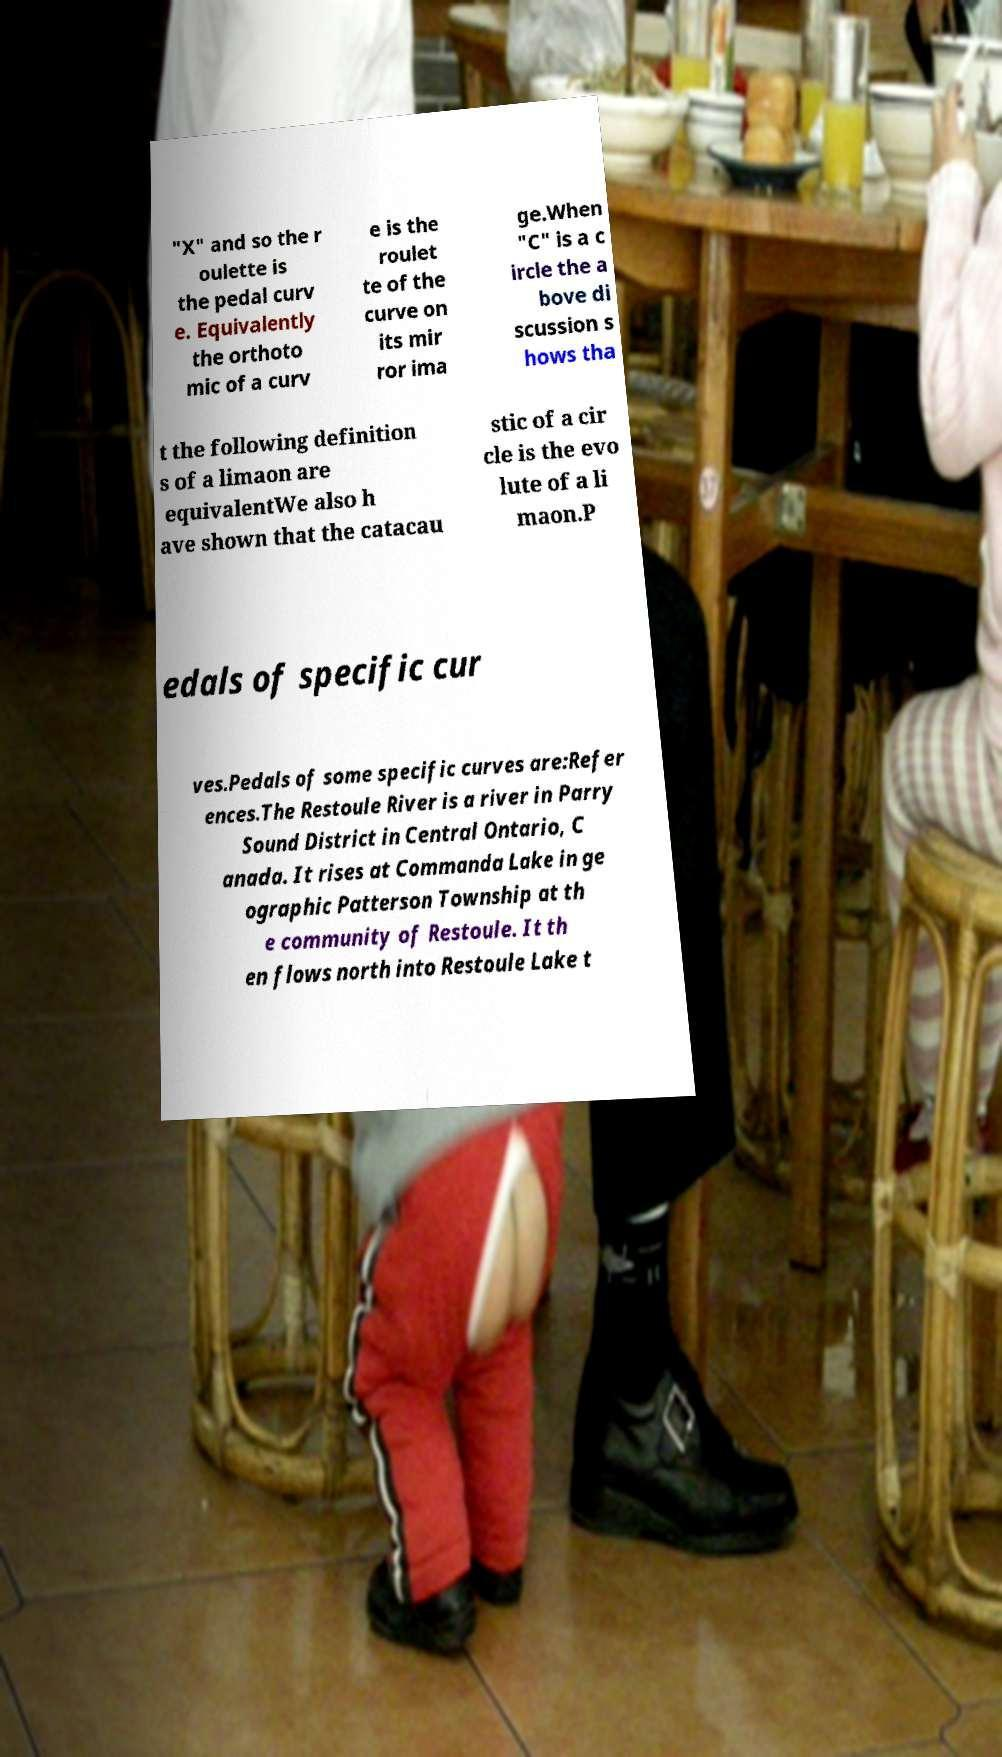For documentation purposes, I need the text within this image transcribed. Could you provide that? "X" and so the r oulette is the pedal curv e. Equivalently the orthoto mic of a curv e is the roulet te of the curve on its mir ror ima ge.When "C" is a c ircle the a bove di scussion s hows tha t the following definition s of a limaon are equivalentWe also h ave shown that the catacau stic of a cir cle is the evo lute of a li maon.P edals of specific cur ves.Pedals of some specific curves are:Refer ences.The Restoule River is a river in Parry Sound District in Central Ontario, C anada. It rises at Commanda Lake in ge ographic Patterson Township at th e community of Restoule. It th en flows north into Restoule Lake t 